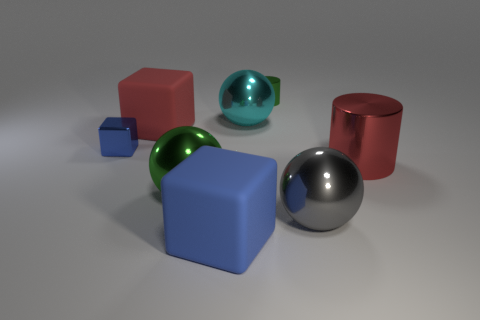Are there more big cylinders that are to the right of the cyan thing than large cubes behind the big red metallic thing?
Make the answer very short. No. Does the red shiny cylinder have the same size as the blue shiny cube?
Offer a terse response. No. There is a shiny cylinder that is behind the rubber thing that is on the left side of the large blue block; what is its color?
Keep it short and to the point. Green. What color is the large cylinder?
Provide a succinct answer. Red. Is there a object that has the same color as the small cube?
Offer a very short reply. Yes. Is the color of the rubber block that is in front of the tiny blue thing the same as the tiny shiny cube?
Make the answer very short. Yes. What number of things are large shiny things to the right of the small green shiny thing or red cubes?
Provide a succinct answer. 3. Are there any metallic balls on the left side of the large gray object?
Give a very brief answer. Yes. What material is the object that is the same color as the large cylinder?
Provide a short and direct response. Rubber. Do the sphere that is on the right side of the cyan metallic object and the tiny blue block have the same material?
Make the answer very short. Yes. 